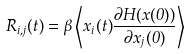<formula> <loc_0><loc_0><loc_500><loc_500>R _ { i , j } ( t ) = \beta \left \langle x _ { i } ( t ) \frac { \partial H ( { x } ( 0 ) ) } { \partial x _ { j } ( 0 ) } \right \rangle</formula> 